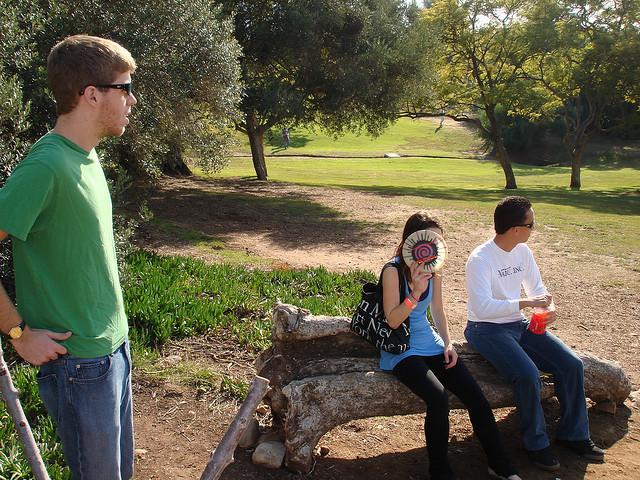Are the men wearing sunglasses?
Give a very brief answer. Yes. What are the people sitting on?
Answer briefly. Log. Are there children in the park?
Answer briefly. No. 